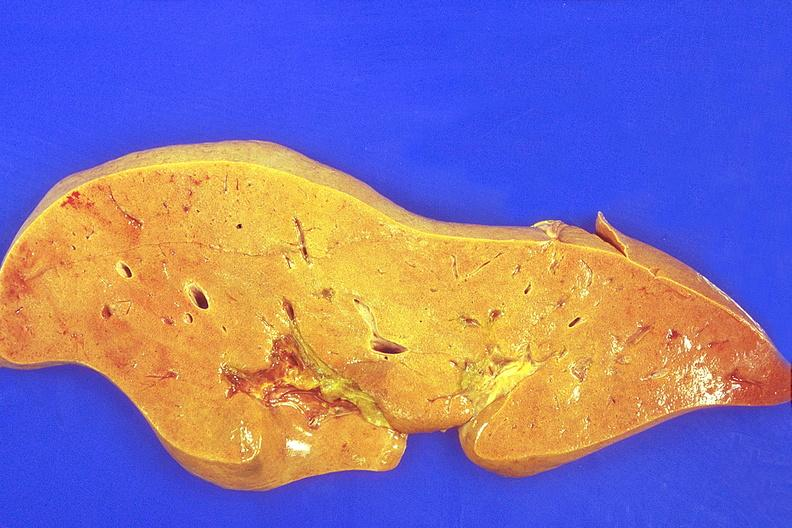s hemorrhage in newborn present?
Answer the question using a single word or phrase. No 